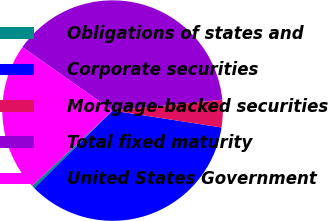Convert chart to OTSL. <chart><loc_0><loc_0><loc_500><loc_500><pie_chart><fcel>Obligations of states and<fcel>Corporate securities<fcel>Mortgage-backed securities<fcel>Total fixed maturity<fcel>United States Government<nl><fcel>0.46%<fcel>35.12%<fcel>4.02%<fcel>38.68%<fcel>21.72%<nl></chart> 